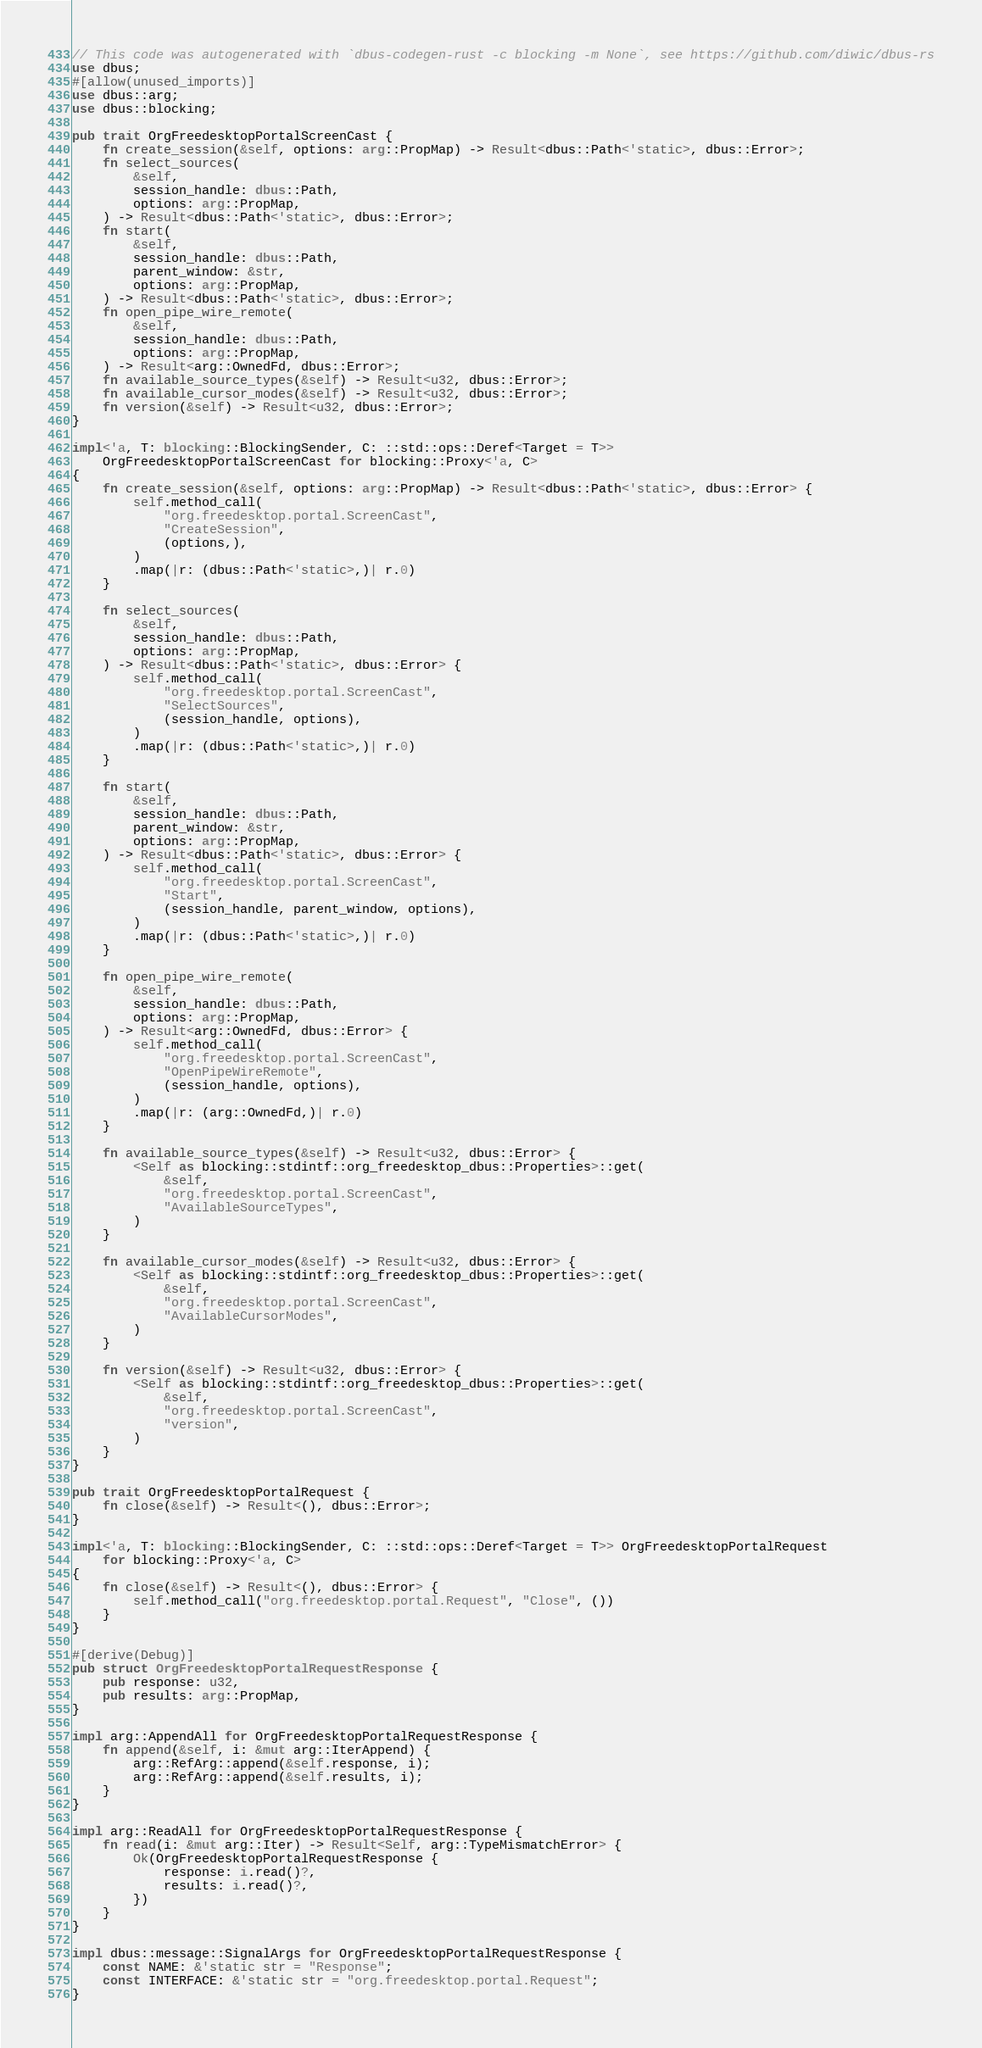<code> <loc_0><loc_0><loc_500><loc_500><_Rust_>// This code was autogenerated with `dbus-codegen-rust -c blocking -m None`, see https://github.com/diwic/dbus-rs
use dbus;
#[allow(unused_imports)]
use dbus::arg;
use dbus::blocking;

pub trait OrgFreedesktopPortalScreenCast {
    fn create_session(&self, options: arg::PropMap) -> Result<dbus::Path<'static>, dbus::Error>;
    fn select_sources(
        &self,
        session_handle: dbus::Path,
        options: arg::PropMap,
    ) -> Result<dbus::Path<'static>, dbus::Error>;
    fn start(
        &self,
        session_handle: dbus::Path,
        parent_window: &str,
        options: arg::PropMap,
    ) -> Result<dbus::Path<'static>, dbus::Error>;
    fn open_pipe_wire_remote(
        &self,
        session_handle: dbus::Path,
        options: arg::PropMap,
    ) -> Result<arg::OwnedFd, dbus::Error>;
    fn available_source_types(&self) -> Result<u32, dbus::Error>;
    fn available_cursor_modes(&self) -> Result<u32, dbus::Error>;
    fn version(&self) -> Result<u32, dbus::Error>;
}

impl<'a, T: blocking::BlockingSender, C: ::std::ops::Deref<Target = T>>
    OrgFreedesktopPortalScreenCast for blocking::Proxy<'a, C>
{
    fn create_session(&self, options: arg::PropMap) -> Result<dbus::Path<'static>, dbus::Error> {
        self.method_call(
            "org.freedesktop.portal.ScreenCast",
            "CreateSession",
            (options,),
        )
        .map(|r: (dbus::Path<'static>,)| r.0)
    }

    fn select_sources(
        &self,
        session_handle: dbus::Path,
        options: arg::PropMap,
    ) -> Result<dbus::Path<'static>, dbus::Error> {
        self.method_call(
            "org.freedesktop.portal.ScreenCast",
            "SelectSources",
            (session_handle, options),
        )
        .map(|r: (dbus::Path<'static>,)| r.0)
    }

    fn start(
        &self,
        session_handle: dbus::Path,
        parent_window: &str,
        options: arg::PropMap,
    ) -> Result<dbus::Path<'static>, dbus::Error> {
        self.method_call(
            "org.freedesktop.portal.ScreenCast",
            "Start",
            (session_handle, parent_window, options),
        )
        .map(|r: (dbus::Path<'static>,)| r.0)
    }

    fn open_pipe_wire_remote(
        &self,
        session_handle: dbus::Path,
        options: arg::PropMap,
    ) -> Result<arg::OwnedFd, dbus::Error> {
        self.method_call(
            "org.freedesktop.portal.ScreenCast",
            "OpenPipeWireRemote",
            (session_handle, options),
        )
        .map(|r: (arg::OwnedFd,)| r.0)
    }

    fn available_source_types(&self) -> Result<u32, dbus::Error> {
        <Self as blocking::stdintf::org_freedesktop_dbus::Properties>::get(
            &self,
            "org.freedesktop.portal.ScreenCast",
            "AvailableSourceTypes",
        )
    }

    fn available_cursor_modes(&self) -> Result<u32, dbus::Error> {
        <Self as blocking::stdintf::org_freedesktop_dbus::Properties>::get(
            &self,
            "org.freedesktop.portal.ScreenCast",
            "AvailableCursorModes",
        )
    }

    fn version(&self) -> Result<u32, dbus::Error> {
        <Self as blocking::stdintf::org_freedesktop_dbus::Properties>::get(
            &self,
            "org.freedesktop.portal.ScreenCast",
            "version",
        )
    }
}

pub trait OrgFreedesktopPortalRequest {
    fn close(&self) -> Result<(), dbus::Error>;
}

impl<'a, T: blocking::BlockingSender, C: ::std::ops::Deref<Target = T>> OrgFreedesktopPortalRequest
    for blocking::Proxy<'a, C>
{
    fn close(&self) -> Result<(), dbus::Error> {
        self.method_call("org.freedesktop.portal.Request", "Close", ())
    }
}

#[derive(Debug)]
pub struct OrgFreedesktopPortalRequestResponse {
    pub response: u32,
    pub results: arg::PropMap,
}

impl arg::AppendAll for OrgFreedesktopPortalRequestResponse {
    fn append(&self, i: &mut arg::IterAppend) {
        arg::RefArg::append(&self.response, i);
        arg::RefArg::append(&self.results, i);
    }
}

impl arg::ReadAll for OrgFreedesktopPortalRequestResponse {
    fn read(i: &mut arg::Iter) -> Result<Self, arg::TypeMismatchError> {
        Ok(OrgFreedesktopPortalRequestResponse {
            response: i.read()?,
            results: i.read()?,
        })
    }
}

impl dbus::message::SignalArgs for OrgFreedesktopPortalRequestResponse {
    const NAME: &'static str = "Response";
    const INTERFACE: &'static str = "org.freedesktop.portal.Request";
}
</code> 